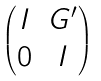<formula> <loc_0><loc_0><loc_500><loc_500>\begin{pmatrix} I & G ^ { \prime } \\ 0 & I \end{pmatrix}</formula> 